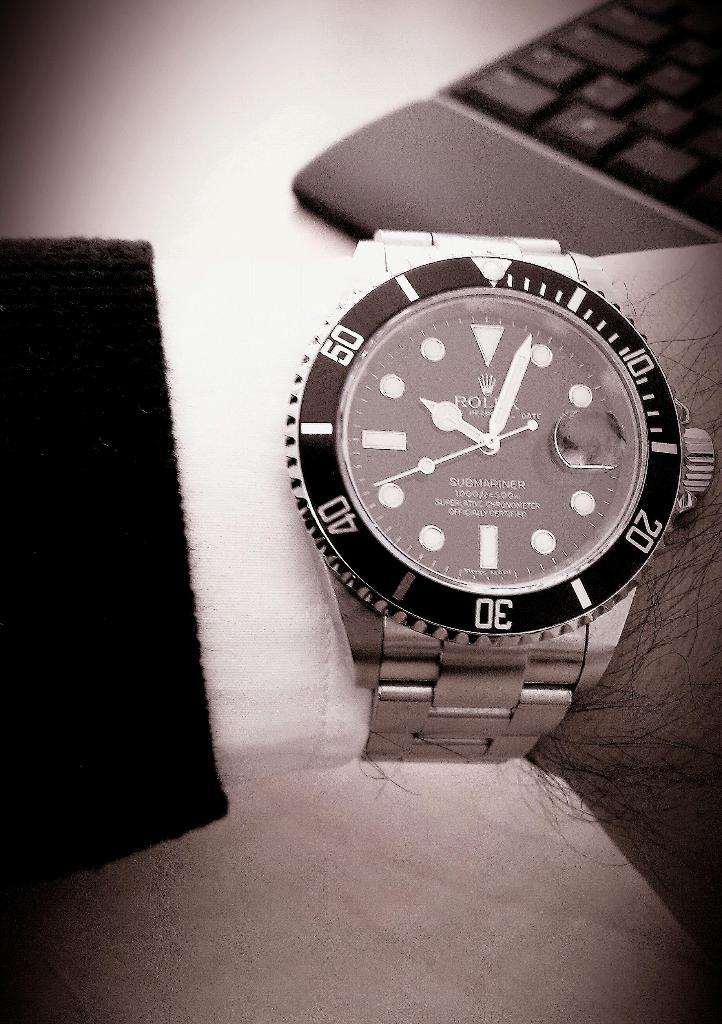<image>
Share a concise interpretation of the image provided. Person wearing a watch which says the name ROLEX on it. 